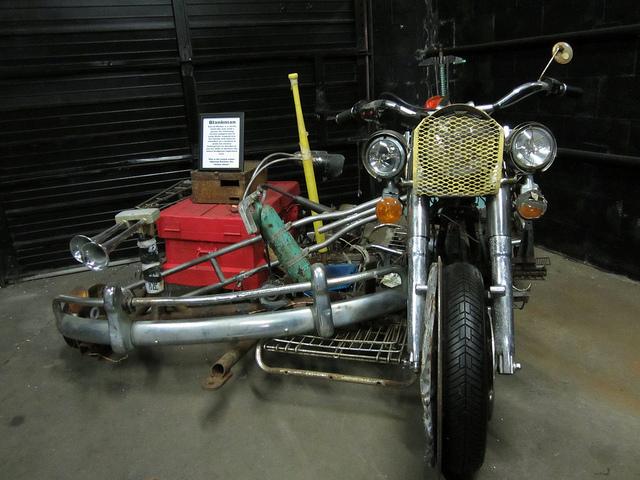How many bikes are in this area?
Write a very short answer. 1. Is the bike being fixed?
Short answer required. Yes. What is the yellow object?
Be succinct. Bat. 